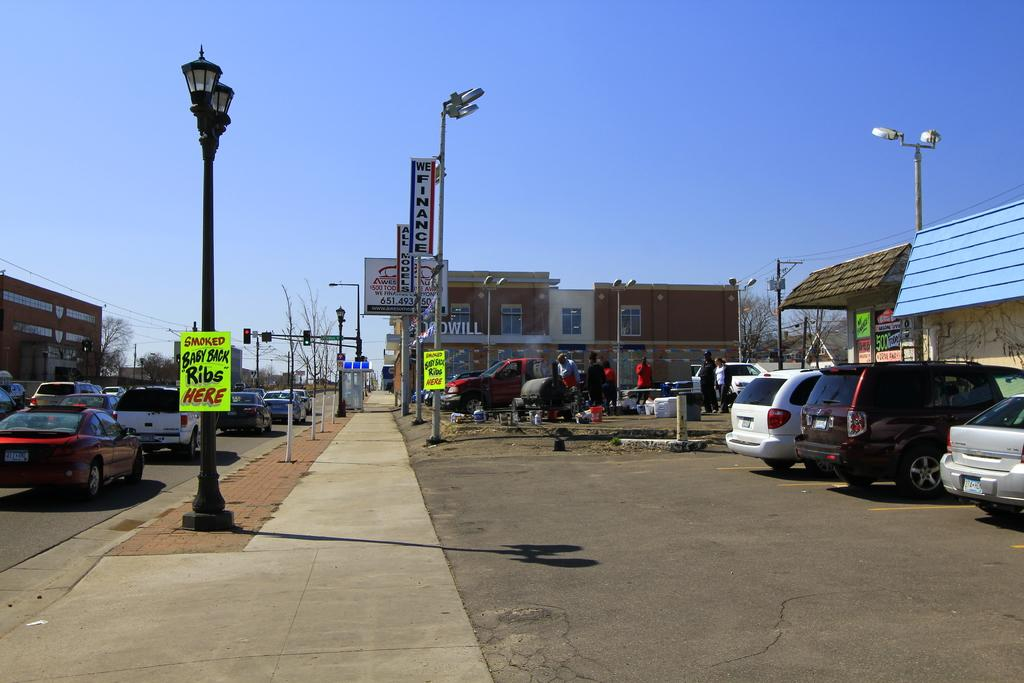What can be seen on the road in the image? There are vehicles on the road in the image. What else can be seen near the road in the image? There are vehicles parked or placed near the road in the image. What type of structures are visible in the image? There are buildings visible in the image. What type of vegetation is present in the image? There are trees present in the image. Can you see any cattle grazing in the image? There is no cattle present in the image; it features vehicles on the road, parked vehicles, buildings, and trees. Is there an airplane flying in the image? There is no airplane visible in the image; it focuses on vehicles, buildings, and trees. 